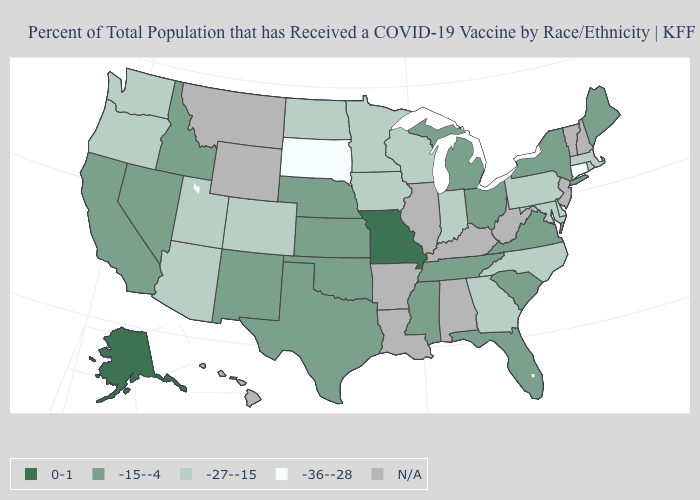How many symbols are there in the legend?
Give a very brief answer. 5. Name the states that have a value in the range 0-1?
Concise answer only. Alaska, Missouri. What is the value of Illinois?
Quick response, please. N/A. What is the value of Nebraska?
Short answer required. -15--4. Does the map have missing data?
Concise answer only. Yes. Among the states that border New Hampshire , which have the lowest value?
Give a very brief answer. Massachusetts. What is the highest value in the USA?
Write a very short answer. 0-1. What is the value of Illinois?
Quick response, please. N/A. Which states have the lowest value in the USA?
Short answer required. Connecticut, South Dakota. What is the value of Tennessee?
Give a very brief answer. -15--4. What is the highest value in the USA?
Quick response, please. 0-1. Name the states that have a value in the range -27--15?
Answer briefly. Arizona, Colorado, Delaware, Georgia, Indiana, Iowa, Maryland, Massachusetts, Minnesota, North Carolina, North Dakota, Oregon, Pennsylvania, Rhode Island, Utah, Washington, Wisconsin. What is the value of Missouri?
Give a very brief answer. 0-1. Does the map have missing data?
Concise answer only. Yes. Among the states that border Delaware , which have the highest value?
Answer briefly. Maryland, Pennsylvania. 